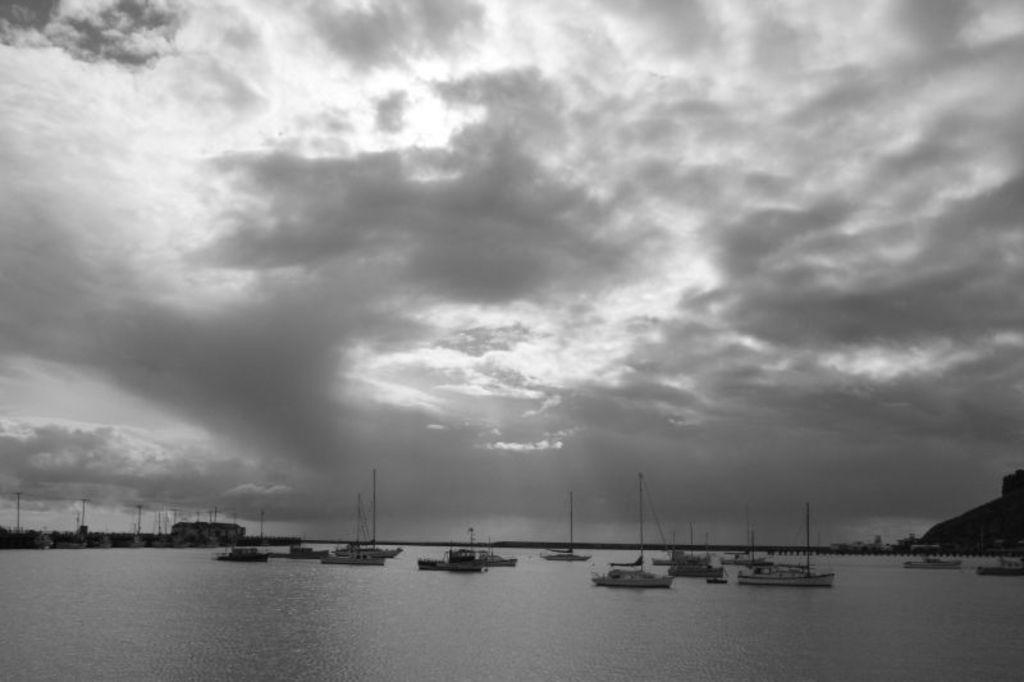What is the main subject of the image? There is a group of boats on water in the image. What structures can be seen in the image? There are sheds in the image. What utility infrastructure is visible in the image? Electric poles are visible in the image. What else can be seen in the image besides the boats, sheds, and electric poles? There are some unspecified objects in the image. What is visible in the background of the image? The sky is visible in the background of the image. How many goldfish are swimming in the water near the boats in the image? There are no goldfish visible in the image; it features a group of boats on water. What type of watch is the person wearing in the image? There is no person wearing a watch in the image. 